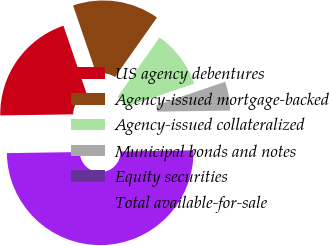Convert chart to OTSL. <chart><loc_0><loc_0><loc_500><loc_500><pie_chart><fcel>US agency debentures<fcel>Agency-issued mortgage-backed<fcel>Agency-issued collateralized<fcel>Municipal bonds and notes<fcel>Equity securities<fcel>Total available-for-sale<nl><fcel>20.0%<fcel>15.0%<fcel>10.0%<fcel>5.0%<fcel>0.0%<fcel>50.0%<nl></chart> 